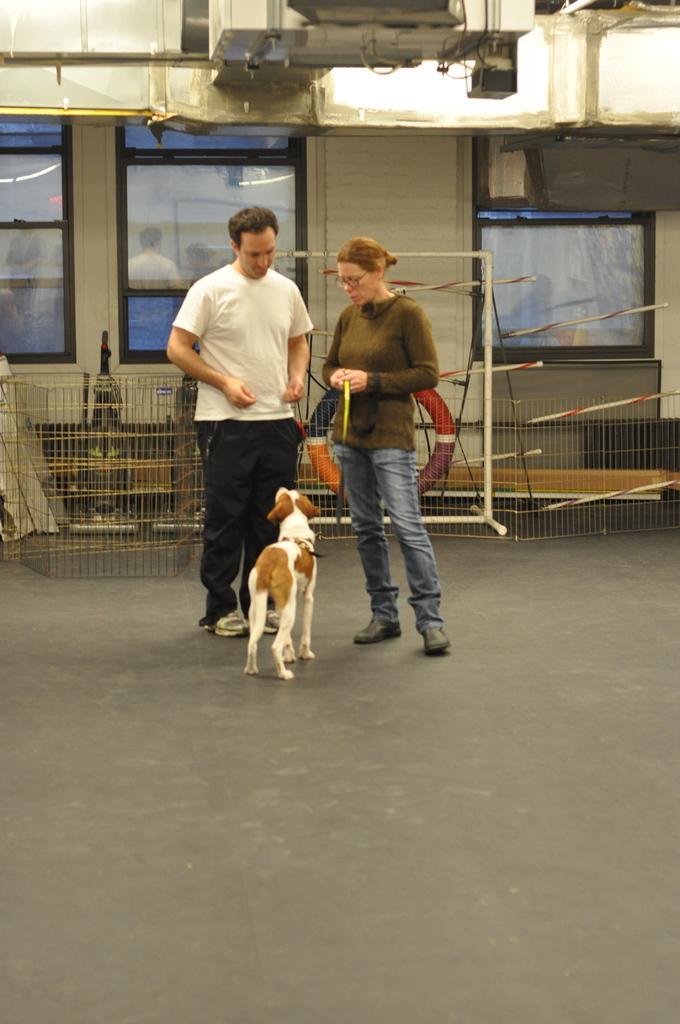In one or two sentences, can you explain what this image depicts? Here in this picture we can see a couple standing on the floor over there and in front of them we can also see a dog present, behind them we can see some bins present and we can see some windows on the building over there and we can also see a life tube present over there. 